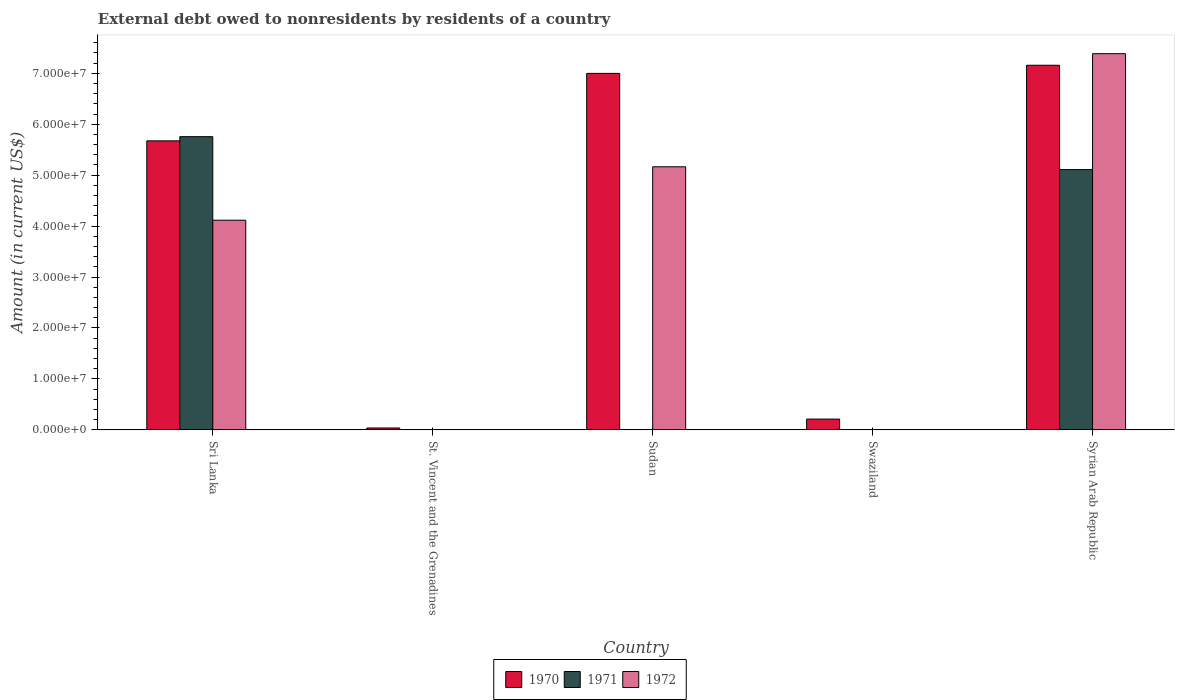How many different coloured bars are there?
Give a very brief answer. 3. Are the number of bars per tick equal to the number of legend labels?
Offer a very short reply. No. Are the number of bars on each tick of the X-axis equal?
Your response must be concise. No. How many bars are there on the 4th tick from the left?
Provide a short and direct response. 1. How many bars are there on the 2nd tick from the right?
Ensure brevity in your answer.  1. What is the label of the 3rd group of bars from the left?
Give a very brief answer. Sudan. In how many cases, is the number of bars for a given country not equal to the number of legend labels?
Offer a very short reply. 2. What is the external debt owed by residents in 1971 in Sri Lanka?
Provide a succinct answer. 5.76e+07. Across all countries, what is the maximum external debt owed by residents in 1972?
Provide a short and direct response. 7.38e+07. Across all countries, what is the minimum external debt owed by residents in 1970?
Give a very brief answer. 3.60e+05. In which country was the external debt owed by residents in 1970 maximum?
Provide a short and direct response. Syrian Arab Republic. What is the total external debt owed by residents in 1972 in the graph?
Provide a succinct answer. 1.67e+08. What is the difference between the external debt owed by residents in 1970 in Swaziland and that in Syrian Arab Republic?
Provide a succinct answer. -6.95e+07. What is the difference between the external debt owed by residents in 1971 in Sri Lanka and the external debt owed by residents in 1972 in Swaziland?
Ensure brevity in your answer.  5.76e+07. What is the average external debt owed by residents in 1970 per country?
Your response must be concise. 4.02e+07. What is the difference between the external debt owed by residents of/in 1972 and external debt owed by residents of/in 1970 in Sri Lanka?
Your answer should be compact. -1.56e+07. What is the ratio of the external debt owed by residents in 1972 in St. Vincent and the Grenadines to that in Syrian Arab Republic?
Provide a short and direct response. 0. Is the difference between the external debt owed by residents in 1972 in Sudan and Syrian Arab Republic greater than the difference between the external debt owed by residents in 1970 in Sudan and Syrian Arab Republic?
Your answer should be compact. No. What is the difference between the highest and the second highest external debt owed by residents in 1972?
Ensure brevity in your answer.  3.27e+07. What is the difference between the highest and the lowest external debt owed by residents in 1972?
Ensure brevity in your answer.  7.38e+07. Is the sum of the external debt owed by residents in 1970 in St. Vincent and the Grenadines and Syrian Arab Republic greater than the maximum external debt owed by residents in 1971 across all countries?
Your answer should be very brief. Yes. Is it the case that in every country, the sum of the external debt owed by residents in 1970 and external debt owed by residents in 1971 is greater than the external debt owed by residents in 1972?
Your response must be concise. Yes. How many countries are there in the graph?
Your answer should be very brief. 5. Does the graph contain any zero values?
Your response must be concise. Yes. Does the graph contain grids?
Your response must be concise. No. How many legend labels are there?
Make the answer very short. 3. What is the title of the graph?
Your answer should be very brief. External debt owed to nonresidents by residents of a country. What is the label or title of the Y-axis?
Ensure brevity in your answer.  Amount (in current US$). What is the Amount (in current US$) of 1970 in Sri Lanka?
Offer a terse response. 5.67e+07. What is the Amount (in current US$) of 1971 in Sri Lanka?
Offer a very short reply. 5.76e+07. What is the Amount (in current US$) in 1972 in Sri Lanka?
Give a very brief answer. 4.12e+07. What is the Amount (in current US$) in 1970 in St. Vincent and the Grenadines?
Make the answer very short. 3.60e+05. What is the Amount (in current US$) of 1971 in St. Vincent and the Grenadines?
Your answer should be compact. 3000. What is the Amount (in current US$) in 1972 in St. Vincent and the Grenadines?
Your response must be concise. 1.50e+04. What is the Amount (in current US$) in 1970 in Sudan?
Your answer should be very brief. 7.00e+07. What is the Amount (in current US$) of 1972 in Sudan?
Offer a very short reply. 5.16e+07. What is the Amount (in current US$) of 1970 in Swaziland?
Make the answer very short. 2.10e+06. What is the Amount (in current US$) of 1970 in Syrian Arab Republic?
Make the answer very short. 7.16e+07. What is the Amount (in current US$) in 1971 in Syrian Arab Republic?
Your answer should be compact. 5.11e+07. What is the Amount (in current US$) of 1972 in Syrian Arab Republic?
Your answer should be very brief. 7.38e+07. Across all countries, what is the maximum Amount (in current US$) in 1970?
Give a very brief answer. 7.16e+07. Across all countries, what is the maximum Amount (in current US$) of 1971?
Your answer should be compact. 5.76e+07. Across all countries, what is the maximum Amount (in current US$) in 1972?
Offer a terse response. 7.38e+07. Across all countries, what is the minimum Amount (in current US$) of 1970?
Your answer should be very brief. 3.60e+05. What is the total Amount (in current US$) of 1970 in the graph?
Make the answer very short. 2.01e+08. What is the total Amount (in current US$) of 1971 in the graph?
Provide a short and direct response. 1.09e+08. What is the total Amount (in current US$) of 1972 in the graph?
Keep it short and to the point. 1.67e+08. What is the difference between the Amount (in current US$) in 1970 in Sri Lanka and that in St. Vincent and the Grenadines?
Provide a succinct answer. 5.64e+07. What is the difference between the Amount (in current US$) of 1971 in Sri Lanka and that in St. Vincent and the Grenadines?
Ensure brevity in your answer.  5.76e+07. What is the difference between the Amount (in current US$) in 1972 in Sri Lanka and that in St. Vincent and the Grenadines?
Your answer should be very brief. 4.11e+07. What is the difference between the Amount (in current US$) of 1970 in Sri Lanka and that in Sudan?
Offer a very short reply. -1.32e+07. What is the difference between the Amount (in current US$) of 1972 in Sri Lanka and that in Sudan?
Ensure brevity in your answer.  -1.05e+07. What is the difference between the Amount (in current US$) in 1970 in Sri Lanka and that in Swaziland?
Offer a terse response. 5.46e+07. What is the difference between the Amount (in current US$) in 1970 in Sri Lanka and that in Syrian Arab Republic?
Ensure brevity in your answer.  -1.48e+07. What is the difference between the Amount (in current US$) in 1971 in Sri Lanka and that in Syrian Arab Republic?
Your answer should be compact. 6.47e+06. What is the difference between the Amount (in current US$) of 1972 in Sri Lanka and that in Syrian Arab Republic?
Your answer should be very brief. -3.27e+07. What is the difference between the Amount (in current US$) in 1970 in St. Vincent and the Grenadines and that in Sudan?
Make the answer very short. -6.96e+07. What is the difference between the Amount (in current US$) in 1972 in St. Vincent and the Grenadines and that in Sudan?
Offer a terse response. -5.16e+07. What is the difference between the Amount (in current US$) of 1970 in St. Vincent and the Grenadines and that in Swaziland?
Offer a very short reply. -1.74e+06. What is the difference between the Amount (in current US$) of 1970 in St. Vincent and the Grenadines and that in Syrian Arab Republic?
Give a very brief answer. -7.12e+07. What is the difference between the Amount (in current US$) in 1971 in St. Vincent and the Grenadines and that in Syrian Arab Republic?
Provide a succinct answer. -5.11e+07. What is the difference between the Amount (in current US$) of 1972 in St. Vincent and the Grenadines and that in Syrian Arab Republic?
Offer a terse response. -7.38e+07. What is the difference between the Amount (in current US$) in 1970 in Sudan and that in Swaziland?
Give a very brief answer. 6.79e+07. What is the difference between the Amount (in current US$) in 1970 in Sudan and that in Syrian Arab Republic?
Your answer should be compact. -1.60e+06. What is the difference between the Amount (in current US$) of 1972 in Sudan and that in Syrian Arab Republic?
Ensure brevity in your answer.  -2.22e+07. What is the difference between the Amount (in current US$) in 1970 in Swaziland and that in Syrian Arab Republic?
Give a very brief answer. -6.95e+07. What is the difference between the Amount (in current US$) of 1970 in Sri Lanka and the Amount (in current US$) of 1971 in St. Vincent and the Grenadines?
Give a very brief answer. 5.67e+07. What is the difference between the Amount (in current US$) of 1970 in Sri Lanka and the Amount (in current US$) of 1972 in St. Vincent and the Grenadines?
Your answer should be very brief. 5.67e+07. What is the difference between the Amount (in current US$) in 1971 in Sri Lanka and the Amount (in current US$) in 1972 in St. Vincent and the Grenadines?
Provide a short and direct response. 5.75e+07. What is the difference between the Amount (in current US$) of 1970 in Sri Lanka and the Amount (in current US$) of 1972 in Sudan?
Provide a short and direct response. 5.09e+06. What is the difference between the Amount (in current US$) in 1971 in Sri Lanka and the Amount (in current US$) in 1972 in Sudan?
Ensure brevity in your answer.  5.91e+06. What is the difference between the Amount (in current US$) of 1970 in Sri Lanka and the Amount (in current US$) of 1971 in Syrian Arab Republic?
Provide a succinct answer. 5.65e+06. What is the difference between the Amount (in current US$) of 1970 in Sri Lanka and the Amount (in current US$) of 1972 in Syrian Arab Republic?
Your response must be concise. -1.71e+07. What is the difference between the Amount (in current US$) of 1971 in Sri Lanka and the Amount (in current US$) of 1972 in Syrian Arab Republic?
Offer a terse response. -1.63e+07. What is the difference between the Amount (in current US$) in 1970 in St. Vincent and the Grenadines and the Amount (in current US$) in 1972 in Sudan?
Offer a very short reply. -5.13e+07. What is the difference between the Amount (in current US$) in 1971 in St. Vincent and the Grenadines and the Amount (in current US$) in 1972 in Sudan?
Offer a terse response. -5.16e+07. What is the difference between the Amount (in current US$) of 1970 in St. Vincent and the Grenadines and the Amount (in current US$) of 1971 in Syrian Arab Republic?
Your answer should be compact. -5.07e+07. What is the difference between the Amount (in current US$) of 1970 in St. Vincent and the Grenadines and the Amount (in current US$) of 1972 in Syrian Arab Republic?
Provide a succinct answer. -7.35e+07. What is the difference between the Amount (in current US$) in 1971 in St. Vincent and the Grenadines and the Amount (in current US$) in 1972 in Syrian Arab Republic?
Your answer should be very brief. -7.38e+07. What is the difference between the Amount (in current US$) of 1970 in Sudan and the Amount (in current US$) of 1971 in Syrian Arab Republic?
Offer a terse response. 1.89e+07. What is the difference between the Amount (in current US$) of 1970 in Sudan and the Amount (in current US$) of 1972 in Syrian Arab Republic?
Provide a succinct answer. -3.87e+06. What is the difference between the Amount (in current US$) of 1970 in Swaziland and the Amount (in current US$) of 1971 in Syrian Arab Republic?
Your response must be concise. -4.90e+07. What is the difference between the Amount (in current US$) of 1970 in Swaziland and the Amount (in current US$) of 1972 in Syrian Arab Republic?
Keep it short and to the point. -7.17e+07. What is the average Amount (in current US$) of 1970 per country?
Provide a succinct answer. 4.02e+07. What is the average Amount (in current US$) in 1971 per country?
Provide a short and direct response. 2.17e+07. What is the average Amount (in current US$) in 1972 per country?
Your answer should be compact. 3.33e+07. What is the difference between the Amount (in current US$) of 1970 and Amount (in current US$) of 1971 in Sri Lanka?
Make the answer very short. -8.21e+05. What is the difference between the Amount (in current US$) in 1970 and Amount (in current US$) in 1972 in Sri Lanka?
Keep it short and to the point. 1.56e+07. What is the difference between the Amount (in current US$) of 1971 and Amount (in current US$) of 1972 in Sri Lanka?
Keep it short and to the point. 1.64e+07. What is the difference between the Amount (in current US$) in 1970 and Amount (in current US$) in 1971 in St. Vincent and the Grenadines?
Your answer should be very brief. 3.57e+05. What is the difference between the Amount (in current US$) of 1970 and Amount (in current US$) of 1972 in St. Vincent and the Grenadines?
Your answer should be compact. 3.45e+05. What is the difference between the Amount (in current US$) in 1971 and Amount (in current US$) in 1972 in St. Vincent and the Grenadines?
Provide a succinct answer. -1.20e+04. What is the difference between the Amount (in current US$) of 1970 and Amount (in current US$) of 1972 in Sudan?
Ensure brevity in your answer.  1.83e+07. What is the difference between the Amount (in current US$) in 1970 and Amount (in current US$) in 1971 in Syrian Arab Republic?
Make the answer very short. 2.05e+07. What is the difference between the Amount (in current US$) of 1970 and Amount (in current US$) of 1972 in Syrian Arab Republic?
Provide a short and direct response. -2.27e+06. What is the difference between the Amount (in current US$) of 1971 and Amount (in current US$) of 1972 in Syrian Arab Republic?
Give a very brief answer. -2.28e+07. What is the ratio of the Amount (in current US$) in 1970 in Sri Lanka to that in St. Vincent and the Grenadines?
Offer a very short reply. 157.59. What is the ratio of the Amount (in current US$) of 1971 in Sri Lanka to that in St. Vincent and the Grenadines?
Your answer should be very brief. 1.92e+04. What is the ratio of the Amount (in current US$) in 1972 in Sri Lanka to that in St. Vincent and the Grenadines?
Provide a succinct answer. 2743.4. What is the ratio of the Amount (in current US$) in 1970 in Sri Lanka to that in Sudan?
Ensure brevity in your answer.  0.81. What is the ratio of the Amount (in current US$) in 1972 in Sri Lanka to that in Sudan?
Keep it short and to the point. 0.8. What is the ratio of the Amount (in current US$) of 1970 in Sri Lanka to that in Swaziland?
Give a very brief answer. 26.95. What is the ratio of the Amount (in current US$) in 1970 in Sri Lanka to that in Syrian Arab Republic?
Give a very brief answer. 0.79. What is the ratio of the Amount (in current US$) in 1971 in Sri Lanka to that in Syrian Arab Republic?
Keep it short and to the point. 1.13. What is the ratio of the Amount (in current US$) of 1972 in Sri Lanka to that in Syrian Arab Republic?
Provide a short and direct response. 0.56. What is the ratio of the Amount (in current US$) of 1970 in St. Vincent and the Grenadines to that in Sudan?
Your answer should be compact. 0.01. What is the ratio of the Amount (in current US$) in 1972 in St. Vincent and the Grenadines to that in Sudan?
Offer a very short reply. 0. What is the ratio of the Amount (in current US$) in 1970 in St. Vincent and the Grenadines to that in Swaziland?
Offer a very short reply. 0.17. What is the ratio of the Amount (in current US$) in 1970 in St. Vincent and the Grenadines to that in Syrian Arab Republic?
Give a very brief answer. 0.01. What is the ratio of the Amount (in current US$) of 1972 in St. Vincent and the Grenadines to that in Syrian Arab Republic?
Your answer should be compact. 0. What is the ratio of the Amount (in current US$) of 1970 in Sudan to that in Swaziland?
Provide a short and direct response. 33.24. What is the ratio of the Amount (in current US$) in 1970 in Sudan to that in Syrian Arab Republic?
Provide a short and direct response. 0.98. What is the ratio of the Amount (in current US$) in 1972 in Sudan to that in Syrian Arab Republic?
Your answer should be compact. 0.7. What is the ratio of the Amount (in current US$) of 1970 in Swaziland to that in Syrian Arab Republic?
Make the answer very short. 0.03. What is the difference between the highest and the second highest Amount (in current US$) in 1970?
Keep it short and to the point. 1.60e+06. What is the difference between the highest and the second highest Amount (in current US$) of 1971?
Make the answer very short. 6.47e+06. What is the difference between the highest and the second highest Amount (in current US$) in 1972?
Offer a very short reply. 2.22e+07. What is the difference between the highest and the lowest Amount (in current US$) in 1970?
Provide a succinct answer. 7.12e+07. What is the difference between the highest and the lowest Amount (in current US$) of 1971?
Keep it short and to the point. 5.76e+07. What is the difference between the highest and the lowest Amount (in current US$) in 1972?
Provide a succinct answer. 7.38e+07. 